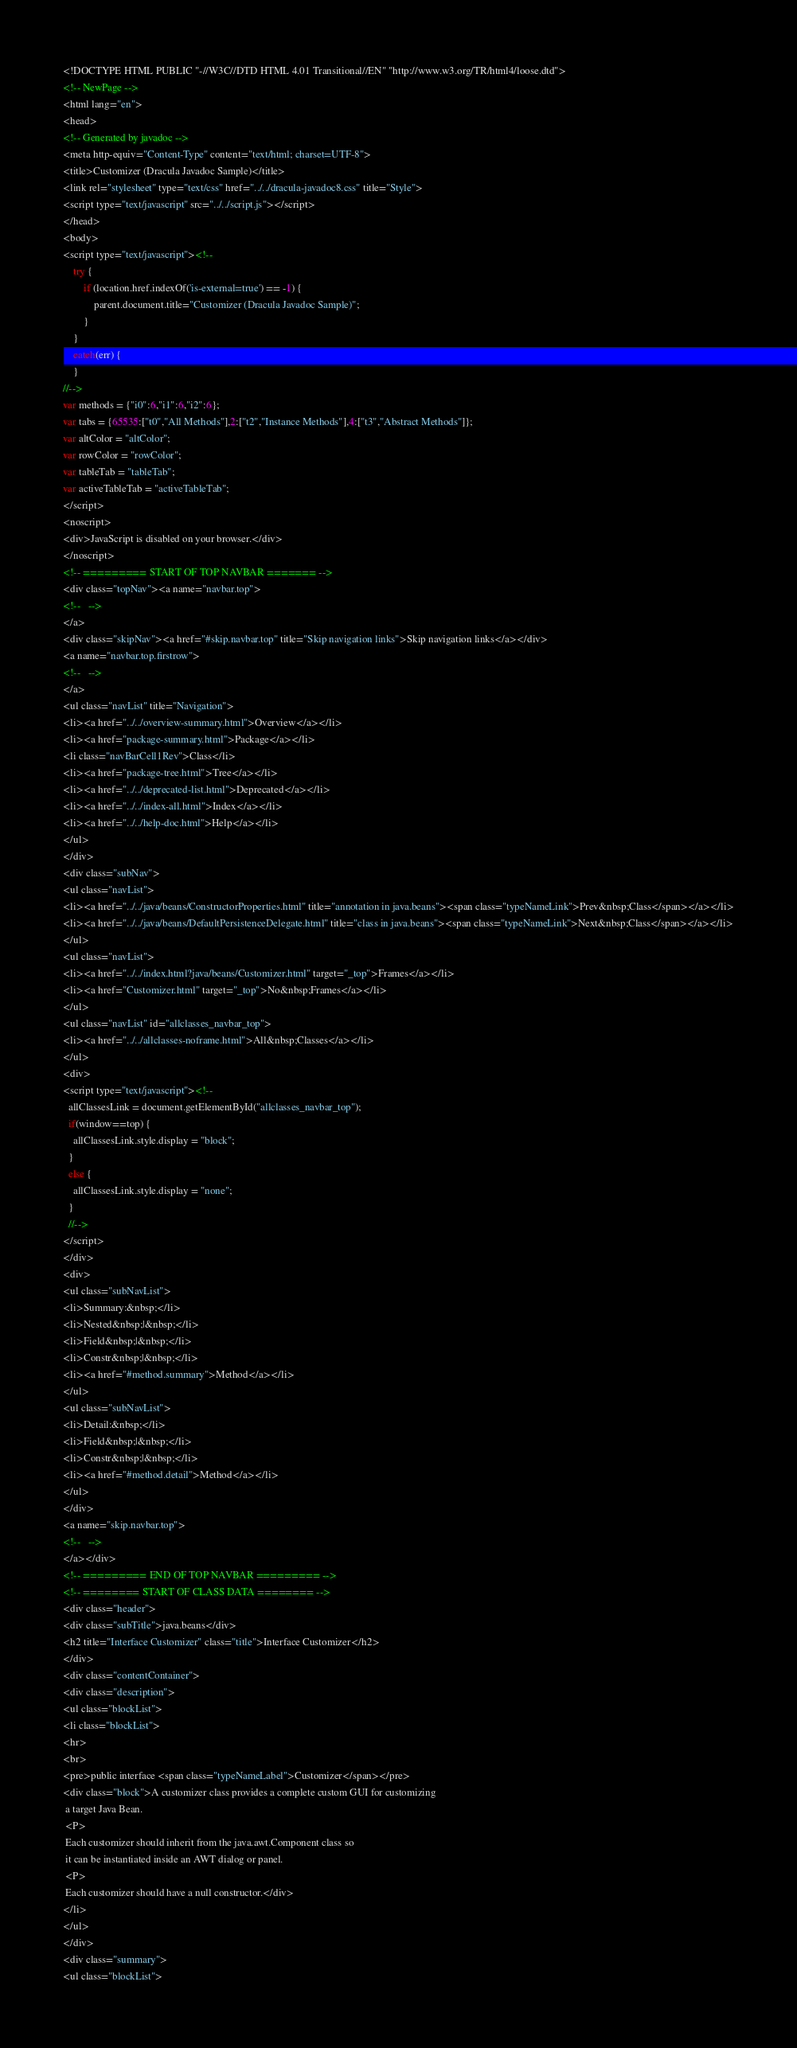<code> <loc_0><loc_0><loc_500><loc_500><_HTML_><!DOCTYPE HTML PUBLIC "-//W3C//DTD HTML 4.01 Transitional//EN" "http://www.w3.org/TR/html4/loose.dtd">
<!-- NewPage -->
<html lang="en">
<head>
<!-- Generated by javadoc -->
<meta http-equiv="Content-Type" content="text/html; charset=UTF-8">
<title>Customizer (Dracula Javadoc Sample)</title>
<link rel="stylesheet" type="text/css" href="../../dracula-javadoc8.css" title="Style">
<script type="text/javascript" src="../../script.js"></script>
</head>
<body>
<script type="text/javascript"><!--
    try {
        if (location.href.indexOf('is-external=true') == -1) {
            parent.document.title="Customizer (Dracula Javadoc Sample)";
        }
    }
    catch(err) {
    }
//-->
var methods = {"i0":6,"i1":6,"i2":6};
var tabs = {65535:["t0","All Methods"],2:["t2","Instance Methods"],4:["t3","Abstract Methods"]};
var altColor = "altColor";
var rowColor = "rowColor";
var tableTab = "tableTab";
var activeTableTab = "activeTableTab";
</script>
<noscript>
<div>JavaScript is disabled on your browser.</div>
</noscript>
<!-- ========= START OF TOP NAVBAR ======= -->
<div class="topNav"><a name="navbar.top">
<!--   -->
</a>
<div class="skipNav"><a href="#skip.navbar.top" title="Skip navigation links">Skip navigation links</a></div>
<a name="navbar.top.firstrow">
<!--   -->
</a>
<ul class="navList" title="Navigation">
<li><a href="../../overview-summary.html">Overview</a></li>
<li><a href="package-summary.html">Package</a></li>
<li class="navBarCell1Rev">Class</li>
<li><a href="package-tree.html">Tree</a></li>
<li><a href="../../deprecated-list.html">Deprecated</a></li>
<li><a href="../../index-all.html">Index</a></li>
<li><a href="../../help-doc.html">Help</a></li>
</ul>
</div>
<div class="subNav">
<ul class="navList">
<li><a href="../../java/beans/ConstructorProperties.html" title="annotation in java.beans"><span class="typeNameLink">Prev&nbsp;Class</span></a></li>
<li><a href="../../java/beans/DefaultPersistenceDelegate.html" title="class in java.beans"><span class="typeNameLink">Next&nbsp;Class</span></a></li>
</ul>
<ul class="navList">
<li><a href="../../index.html?java/beans/Customizer.html" target="_top">Frames</a></li>
<li><a href="Customizer.html" target="_top">No&nbsp;Frames</a></li>
</ul>
<ul class="navList" id="allclasses_navbar_top">
<li><a href="../../allclasses-noframe.html">All&nbsp;Classes</a></li>
</ul>
<div>
<script type="text/javascript"><!--
  allClassesLink = document.getElementById("allclasses_navbar_top");
  if(window==top) {
    allClassesLink.style.display = "block";
  }
  else {
    allClassesLink.style.display = "none";
  }
  //-->
</script>
</div>
<div>
<ul class="subNavList">
<li>Summary:&nbsp;</li>
<li>Nested&nbsp;|&nbsp;</li>
<li>Field&nbsp;|&nbsp;</li>
<li>Constr&nbsp;|&nbsp;</li>
<li><a href="#method.summary">Method</a></li>
</ul>
<ul class="subNavList">
<li>Detail:&nbsp;</li>
<li>Field&nbsp;|&nbsp;</li>
<li>Constr&nbsp;|&nbsp;</li>
<li><a href="#method.detail">Method</a></li>
</ul>
</div>
<a name="skip.navbar.top">
<!--   -->
</a></div>
<!-- ========= END OF TOP NAVBAR ========= -->
<!-- ======== START OF CLASS DATA ======== -->
<div class="header">
<div class="subTitle">java.beans</div>
<h2 title="Interface Customizer" class="title">Interface Customizer</h2>
</div>
<div class="contentContainer">
<div class="description">
<ul class="blockList">
<li class="blockList">
<hr>
<br>
<pre>public interface <span class="typeNameLabel">Customizer</span></pre>
<div class="block">A customizer class provides a complete custom GUI for customizing
 a target Java Bean.
 <P>
 Each customizer should inherit from the java.awt.Component class so
 it can be instantiated inside an AWT dialog or panel.
 <P>
 Each customizer should have a null constructor.</div>
</li>
</ul>
</div>
<div class="summary">
<ul class="blockList"></code> 